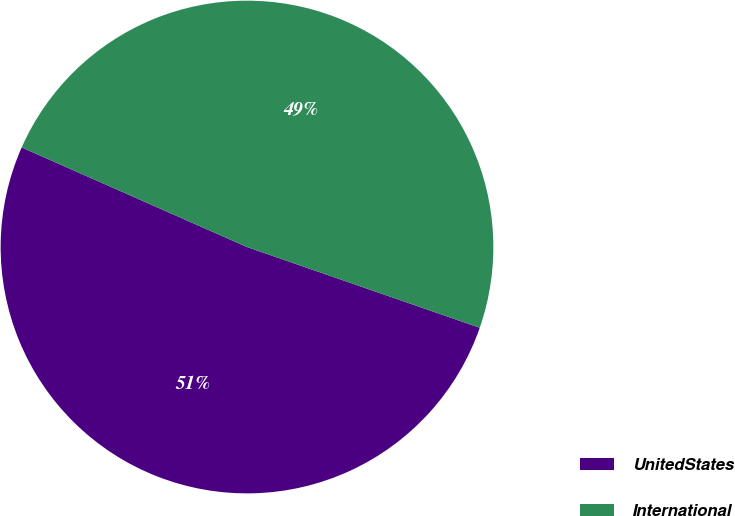Convert chart to OTSL. <chart><loc_0><loc_0><loc_500><loc_500><pie_chart><fcel>UnitedStates<fcel>International<nl><fcel>51.31%<fcel>48.69%<nl></chart> 